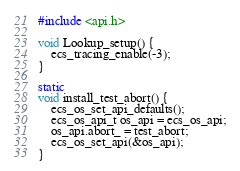<code> <loc_0><loc_0><loc_500><loc_500><_C_>#include <api.h>

void Lookup_setup() {
    ecs_tracing_enable(-3);
}

static
void install_test_abort() {
    ecs_os_set_api_defaults();
    ecs_os_api_t os_api = ecs_os_api;
    os_api.abort_ = test_abort;
    ecs_os_set_api(&os_api);
}
</code> 